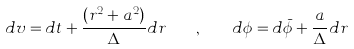<formula> <loc_0><loc_0><loc_500><loc_500>d v = d t + \frac { ( r ^ { 2 } + a ^ { 2 } ) } { \Delta } d r \quad , \quad d \phi = d \bar { \phi } + \frac { a } { \Delta } d r</formula> 